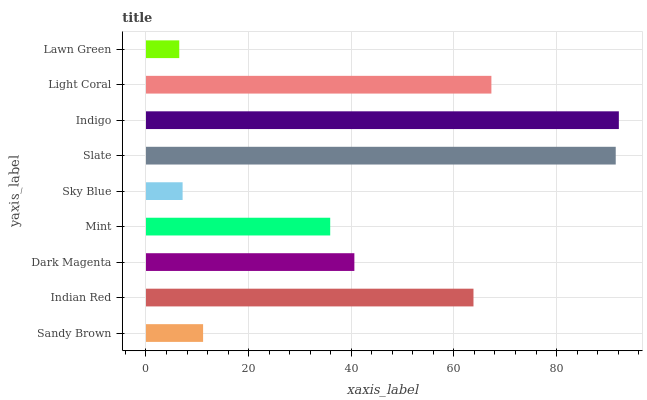Is Lawn Green the minimum?
Answer yes or no. Yes. Is Indigo the maximum?
Answer yes or no. Yes. Is Indian Red the minimum?
Answer yes or no. No. Is Indian Red the maximum?
Answer yes or no. No. Is Indian Red greater than Sandy Brown?
Answer yes or no. Yes. Is Sandy Brown less than Indian Red?
Answer yes or no. Yes. Is Sandy Brown greater than Indian Red?
Answer yes or no. No. Is Indian Red less than Sandy Brown?
Answer yes or no. No. Is Dark Magenta the high median?
Answer yes or no. Yes. Is Dark Magenta the low median?
Answer yes or no. Yes. Is Light Coral the high median?
Answer yes or no. No. Is Mint the low median?
Answer yes or no. No. 